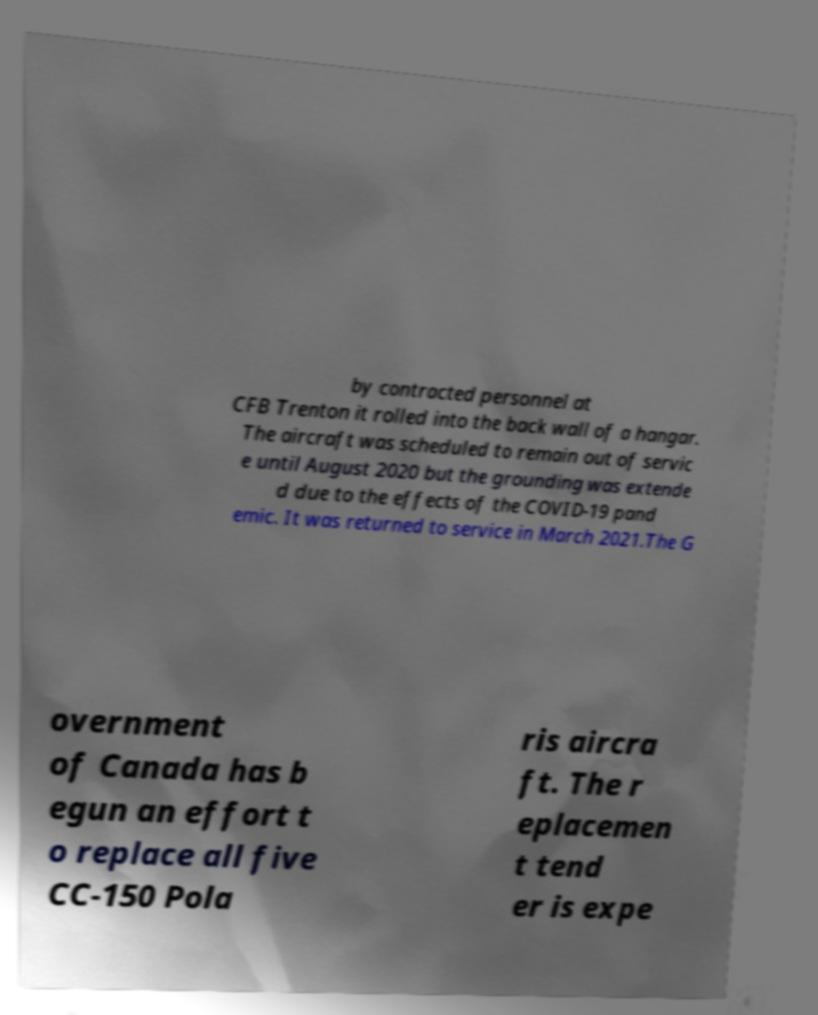Could you extract and type out the text from this image? by contracted personnel at CFB Trenton it rolled into the back wall of a hangar. The aircraft was scheduled to remain out of servic e until August 2020 but the grounding was extende d due to the effects of the COVID-19 pand emic. It was returned to service in March 2021.The G overnment of Canada has b egun an effort t o replace all five CC-150 Pola ris aircra ft. The r eplacemen t tend er is expe 